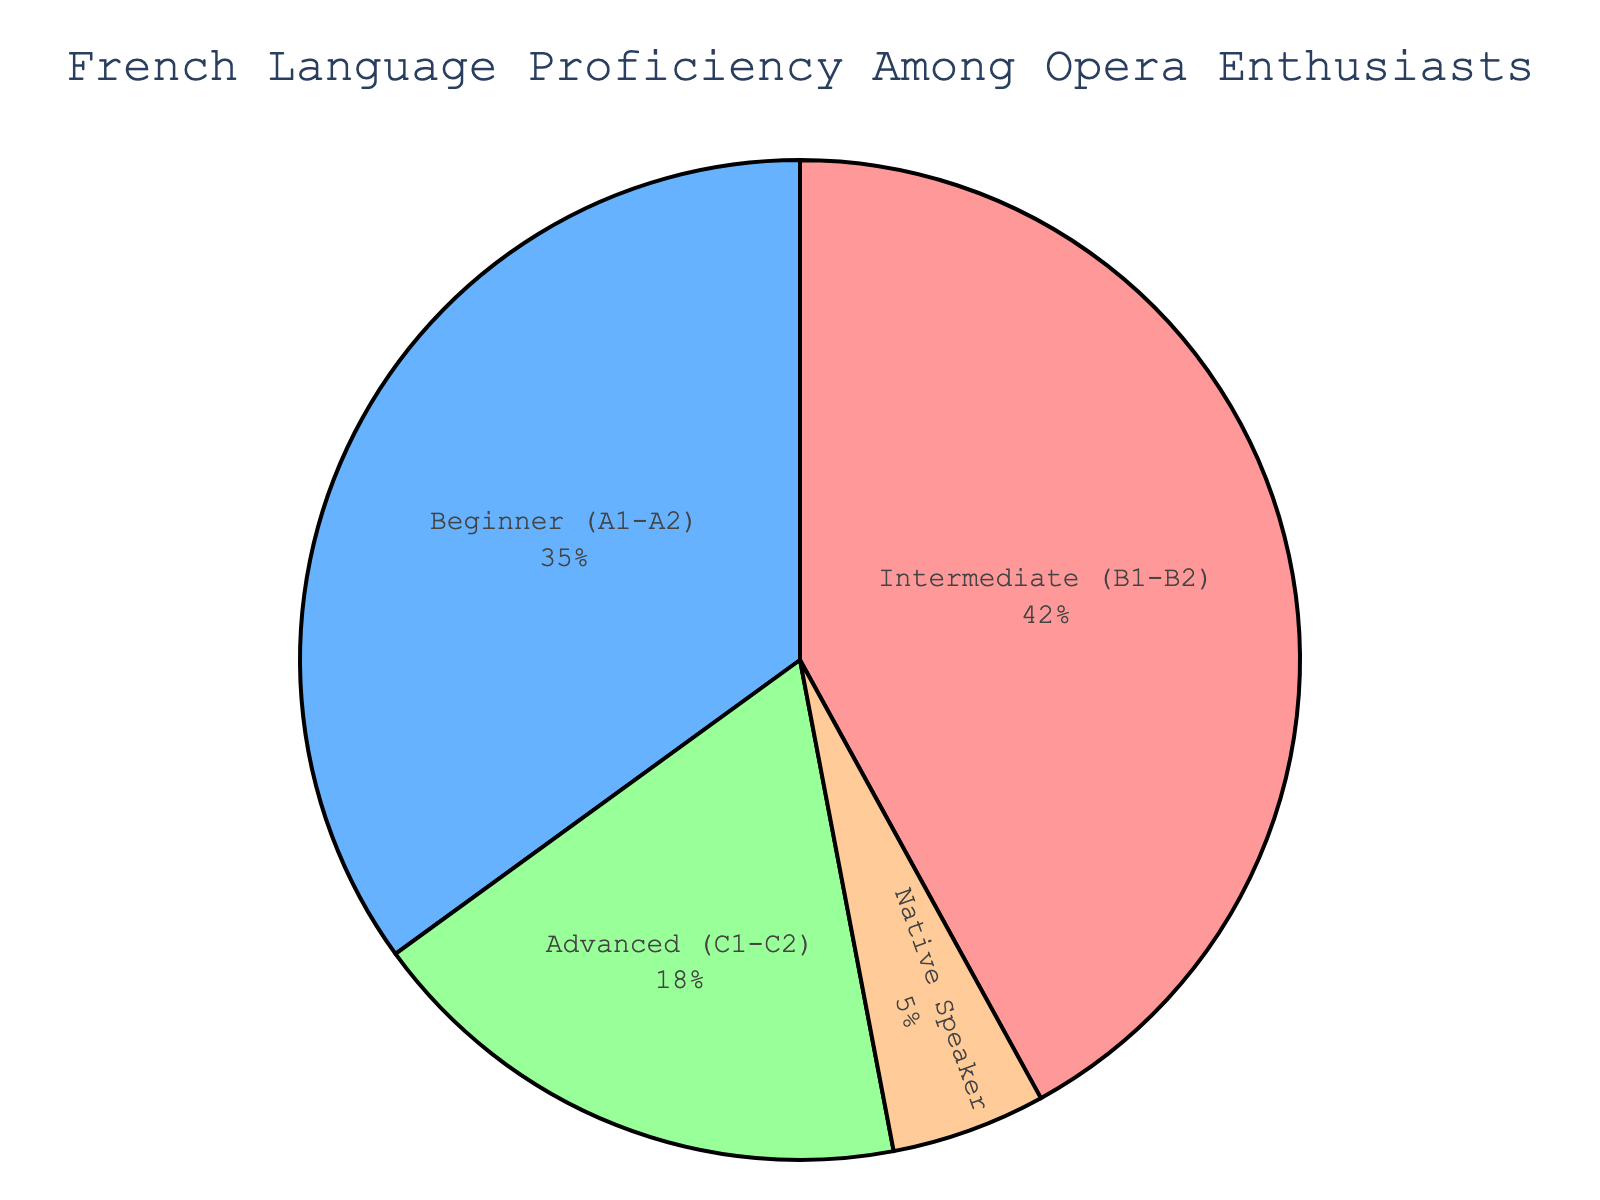What proportion of opera enthusiasts are either at the beginner (A1-A2) or intermediate (B1-B2) level in French? The pie chart shows that 35% are at the beginner level and 42% are at the intermediate level. Adding these two percentages gives 35 + 42 = 77%.
Answer: 77% Which proficiency level has the smallest representation among opera enthusiasts? The pie chart shows that native speakers make up 5% of the total, which is the smallest percentage compared to the other levels.
Answer: Native Speaker How much more significant is the intermediate (B1-B2) group compared to the advanced (C1-C2) group? The intermediate level is 42% and the advanced level is 18%. The difference is 42 - 18 = 24%.
Answer: 24% Can you calculate the combined percentage of enthusiasts who are either at the advanced (C1-C2) level or are native speakers? The pie chart shows that 18% are at the advanced level and 5% are native speakers. Adding these two percentages gives 18 + 5 = 23%.
Answer: 23% What are the color representations for the different levels of French proficiency? The pie chart uses colors to differentiate levels: beginner (pink), intermediate (blue), advanced (green), and native speaker (orange).
Answer: Beginner: pink, Intermediate: blue, Advanced: green, Native Speaker: orange Is the intermediate level the largest group among the opera enthusiasts? Yes, the pie chart shows that the intermediate level makes up 42%, which is the largest proportion compared to the other levels.
Answer: Yes How does the proportion of intermediate speakers compare to the total of advanced speakers and native speakers combined? Intermediate speakers make up 42%, while advanced speakers and native speakers combined make up 18% + 5% = 23%. Therefore, the intermediate level is larger.
Answer: Intermediate is larger By how many percentage points does the beginner (A1-A2) group exceed the advanced (C1-C2) group? The pie chart shows that the beginner level is 35% and the advanced level is 18%. The difference is 35 - 18 = 17%.
Answer: 17% What percentage of opera enthusiasts are non-native French speakers? The pie chart shows that 5% are native speakers, so non-native speakers make up 100% - 5% = 95%.
Answer: 95% 